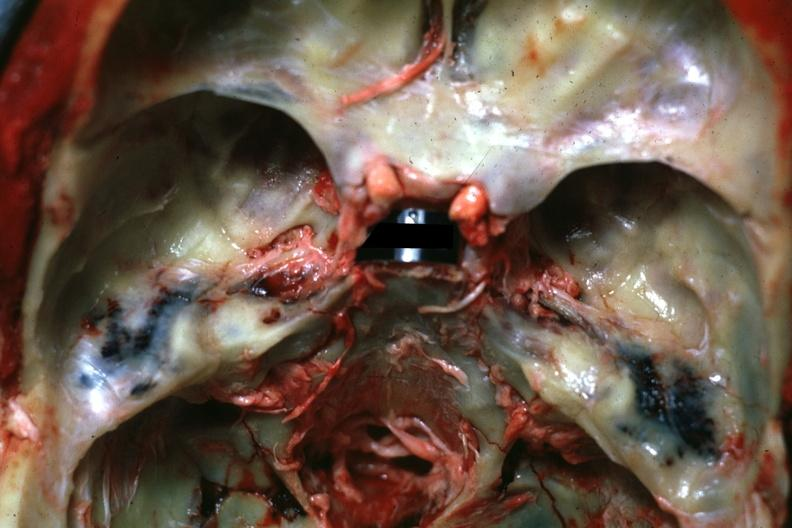what is present?
Answer the question using a single word or phrase. Bone, calvarium 